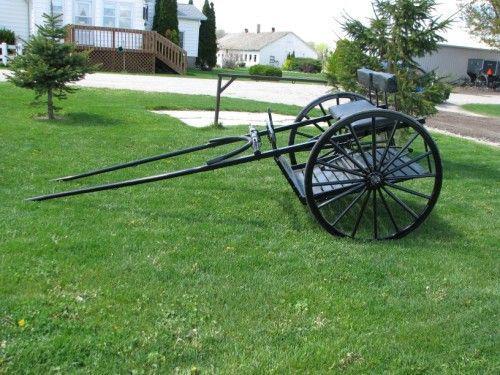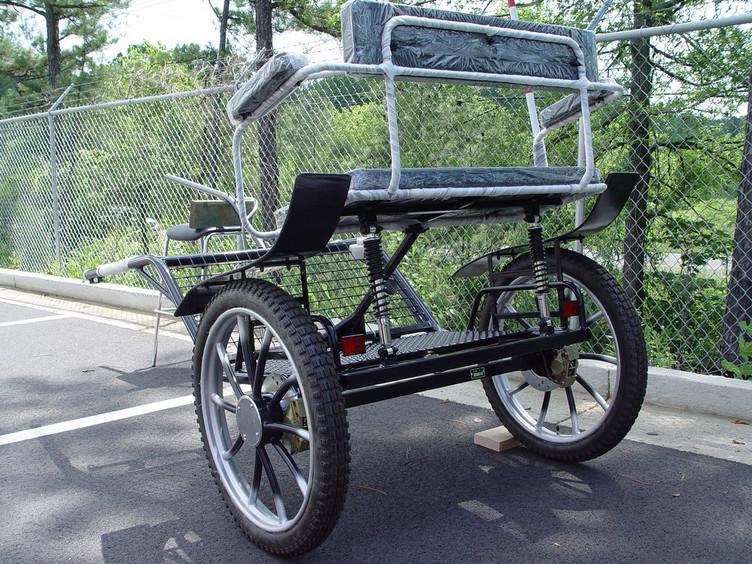The first image is the image on the left, the second image is the image on the right. Considering the images on both sides, is "There is a carriage next to a paved road in the left image." valid? Answer yes or no. No. The first image is the image on the left, the second image is the image on the right. For the images displayed, is the sentence "Both carriages are facing right." factually correct? Answer yes or no. No. 